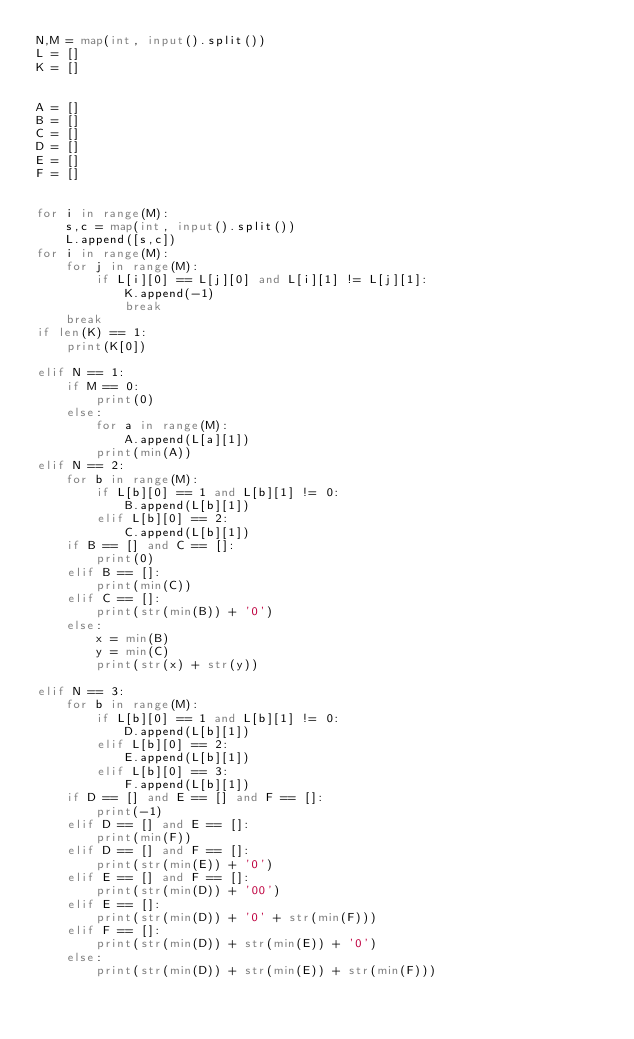Convert code to text. <code><loc_0><loc_0><loc_500><loc_500><_Python_>N,M = map(int, input().split())
L = []
K = []


A = []
B = []
C = []
D = []
E = []
F = []


for i in range(M):
    s,c = map(int, input().split())
    L.append([s,c])
for i in range(M):
    for j in range(M):
        if L[i][0] == L[j][0] and L[i][1] != L[j][1]:
            K.append(-1)
            break
    break
if len(K) == 1:
    print(K[0])

elif N == 1:
    if M == 0:
        print(0)
    else:
        for a in range(M):
            A.append(L[a][1])
        print(min(A))
elif N == 2:
    for b in range(M):
        if L[b][0] == 1 and L[b][1] != 0:
            B.append(L[b][1])
        elif L[b][0] == 2:
            C.append(L[b][1])
    if B == [] and C == []:
        print(0)
    elif B == []:
        print(min(C))
    elif C == []:
        print(str(min(B)) + '0')
    else:
        x = min(B)
        y = min(C)
        print(str(x) + str(y))

elif N == 3:
    for b in range(M):
        if L[b][0] == 1 and L[b][1] != 0:
            D.append(L[b][1])
        elif L[b][0] == 2:
            E.append(L[b][1])
        elif L[b][0] == 3:
            F.append(L[b][1])
    if D == [] and E == [] and F == []:
        print(-1)
    elif D == [] and E == []:
        print(min(F))
    elif D == [] and F == []:
        print(str(min(E)) + '0')
    elif E == [] and F == []:
        print(str(min(D)) + '00')
    elif E == []:
        print(str(min(D)) + '0' + str(min(F)))
    elif F == []:
        print(str(min(D)) + str(min(E)) + '0')
    else:
        print(str(min(D)) + str(min(E)) + str(min(F)))</code> 